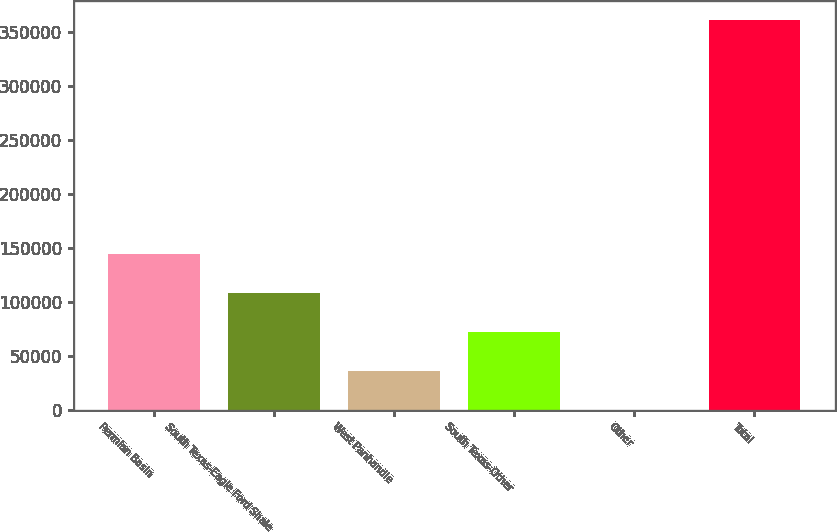Convert chart. <chart><loc_0><loc_0><loc_500><loc_500><bar_chart><fcel>Permian Basin<fcel>South Texas-Eagle Ford Shale<fcel>West Panhandle<fcel>South Texas-Other<fcel>Other<fcel>Total<nl><fcel>144318<fcel>108261<fcel>36146.3<fcel>72203.6<fcel>89<fcel>360662<nl></chart> 